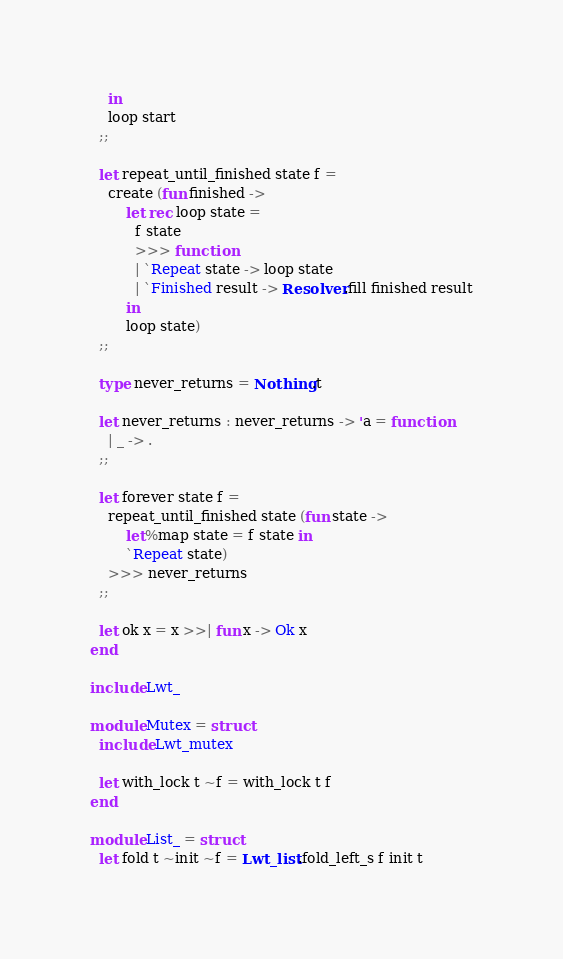<code> <loc_0><loc_0><loc_500><loc_500><_OCaml_>    in
    loop start
  ;;

  let repeat_until_finished state f =
    create (fun finished ->
        let rec loop state =
          f state
          >>> function
          | `Repeat state -> loop state
          | `Finished result -> Resolver.fill finished result
        in
        loop state)
  ;;

  type never_returns = Nothing.t

  let never_returns : never_returns -> 'a = function
    | _ -> .
  ;;

  let forever state f =
    repeat_until_finished state (fun state ->
        let%map state = f state in
        `Repeat state)
    >>> never_returns
  ;;

  let ok x = x >>| fun x -> Ok x
end

include Lwt_

module Mutex = struct
  include Lwt_mutex

  let with_lock t ~f = with_lock t f
end

module List_ = struct
  let fold t ~init ~f = Lwt_list.fold_left_s f init t
</code> 